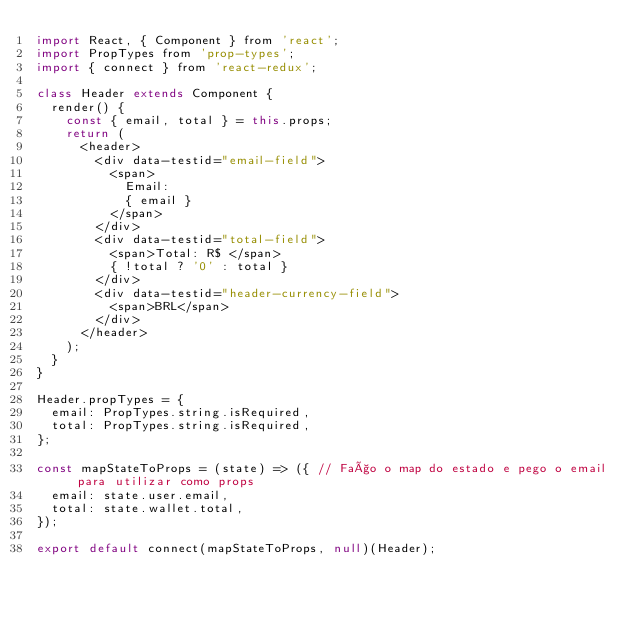Convert code to text. <code><loc_0><loc_0><loc_500><loc_500><_JavaScript_>import React, { Component } from 'react';
import PropTypes from 'prop-types';
import { connect } from 'react-redux';

class Header extends Component {
  render() {
    const { email, total } = this.props;
    return (
      <header>
        <div data-testid="email-field">
          <span>
            Email:
            { email }
          </span>
        </div>
        <div data-testid="total-field">
          <span>Total: R$ </span>
          { !total ? '0' : total }
        </div>
        <div data-testid="header-currency-field">
          <span>BRL</span>
        </div>
      </header>
    );
  }
}

Header.propTypes = {
  email: PropTypes.string.isRequired,
  total: PropTypes.string.isRequired,
};

const mapStateToProps = (state) => ({ // Faço o map do estado e pego o email para utilizar como props
  email: state.user.email,
  total: state.wallet.total,
});

export default connect(mapStateToProps, null)(Header);
</code> 